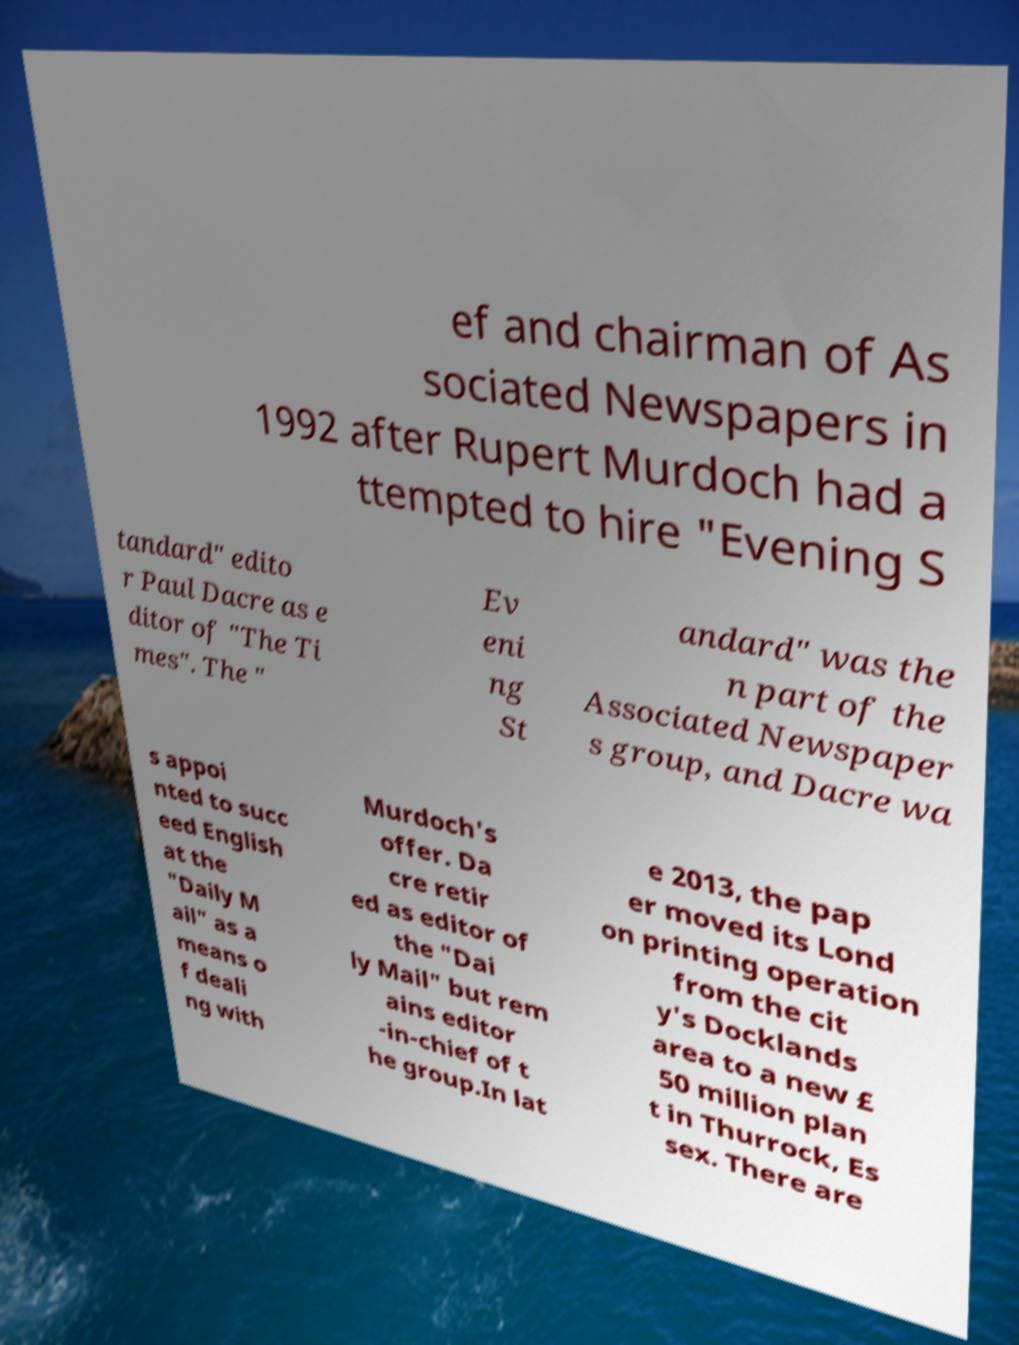Could you extract and type out the text from this image? ef and chairman of As sociated Newspapers in 1992 after Rupert Murdoch had a ttempted to hire "Evening S tandard" edito r Paul Dacre as e ditor of "The Ti mes". The " Ev eni ng St andard" was the n part of the Associated Newspaper s group, and Dacre wa s appoi nted to succ eed English at the "Daily M ail" as a means o f deali ng with Murdoch's offer. Da cre retir ed as editor of the "Dai ly Mail" but rem ains editor -in-chief of t he group.In lat e 2013, the pap er moved its Lond on printing operation from the cit y's Docklands area to a new £ 50 million plan t in Thurrock, Es sex. There are 